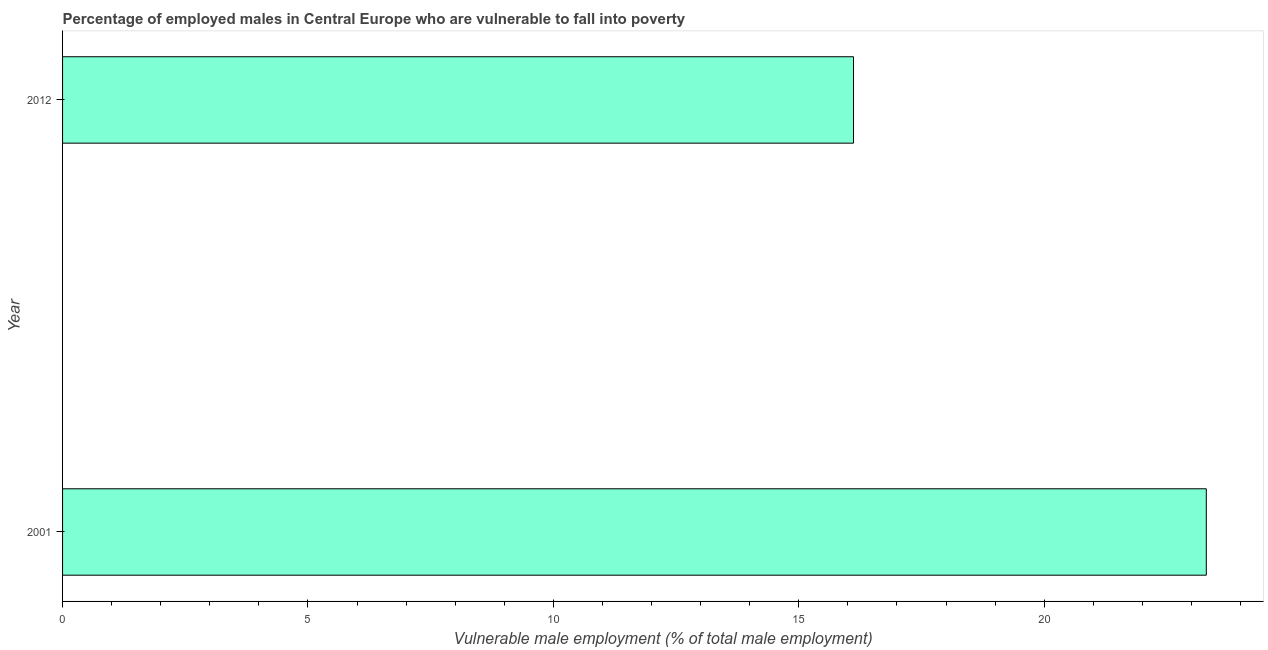Does the graph contain any zero values?
Ensure brevity in your answer.  No. What is the title of the graph?
Provide a succinct answer. Percentage of employed males in Central Europe who are vulnerable to fall into poverty. What is the label or title of the X-axis?
Provide a short and direct response. Vulnerable male employment (% of total male employment). What is the label or title of the Y-axis?
Offer a very short reply. Year. What is the percentage of employed males who are vulnerable to fall into poverty in 2001?
Ensure brevity in your answer.  23.3. Across all years, what is the maximum percentage of employed males who are vulnerable to fall into poverty?
Make the answer very short. 23.3. Across all years, what is the minimum percentage of employed males who are vulnerable to fall into poverty?
Your response must be concise. 16.11. What is the sum of the percentage of employed males who are vulnerable to fall into poverty?
Keep it short and to the point. 39.42. What is the difference between the percentage of employed males who are vulnerable to fall into poverty in 2001 and 2012?
Give a very brief answer. 7.19. What is the average percentage of employed males who are vulnerable to fall into poverty per year?
Your response must be concise. 19.71. What is the median percentage of employed males who are vulnerable to fall into poverty?
Offer a very short reply. 19.71. In how many years, is the percentage of employed males who are vulnerable to fall into poverty greater than 17 %?
Provide a succinct answer. 1. Do a majority of the years between 2001 and 2012 (inclusive) have percentage of employed males who are vulnerable to fall into poverty greater than 17 %?
Your response must be concise. No. What is the ratio of the percentage of employed males who are vulnerable to fall into poverty in 2001 to that in 2012?
Offer a very short reply. 1.45. What is the difference between two consecutive major ticks on the X-axis?
Ensure brevity in your answer.  5. What is the Vulnerable male employment (% of total male employment) of 2001?
Offer a very short reply. 23.3. What is the Vulnerable male employment (% of total male employment) of 2012?
Provide a succinct answer. 16.11. What is the difference between the Vulnerable male employment (% of total male employment) in 2001 and 2012?
Ensure brevity in your answer.  7.19. What is the ratio of the Vulnerable male employment (% of total male employment) in 2001 to that in 2012?
Provide a short and direct response. 1.45. 